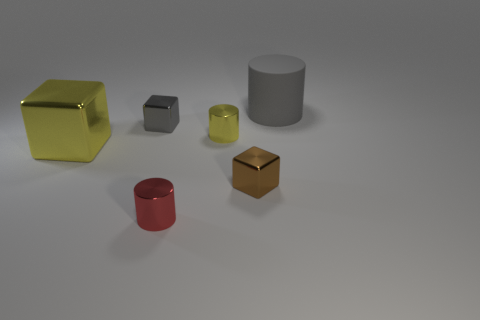What can you tell me about the different colors of the objects in this image? The image features objects in various colors: a glossy yellow cube, a smaller grey cube, a matte grey cylinder, a smaller yellow-green translucent cube, a matte red cylinder, and a brown matte cube. The colors and finishes provide a diverse visual texture and could be interpreted as an exploration of color theory or material properties in a staged setting. 